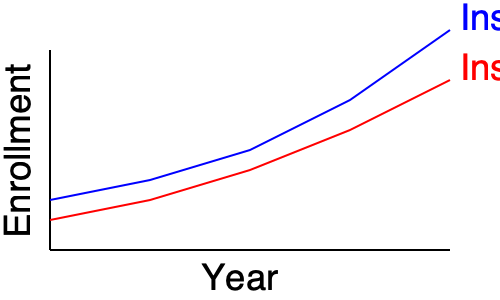Based on the line graph showing enrollment trends for two educational institutes over 5 years, which institute has a higher growth rate? How could this information be used to argue against a proposed tie-up between these institutes? To determine which institute has a higher growth rate and how this information could be used to argue against a proposed tie-up, we need to analyze the graph and consider the implications:

1. Analyze the slopes:
   - Institute A (blue line) has a steeper slope, indicating a faster rate of growth.
   - Institute B (red line) has a more gradual slope, showing slower growth.

2. Compare final positions:
   - By the end of the 5-year period, Institute A has surpassed Institute B in enrollment.

3. Calculate growth rates:
   - Institute A: Started at approximately 200 and ended at 470, a growth of about 135%
   - Institute B: Started at approximately 180 and ended at 370, a growth of about 106%

4. Argument against the tie-up:
   a) Superior performance: Institute A is outperforming Institute B in terms of growth.
   b) Risk of dilution: Merging with a slower-growing institute could hinder Institute A's rapid expansion.
   c) Competitive advantage: Institute A's higher growth rate suggests better strategies or programs, which could be compromised in a tie-up.
   d) Market perception: A tie-up with a slower-growing institute might be seen as a step backward for Institute A.
   e) Resource allocation: Institute A might have to divert resources to support Institute B's growth, potentially slowing its own progress.

5. Conclusion:
   The higher growth rate of Institute A can be used to argue that a tie-up is unnecessary and potentially detrimental to its continued success and market position.
Answer: Institute A has a higher growth rate. This can be used to argue that a tie-up is unnecessary and potentially harmful to Institute A's superior performance and market position. 